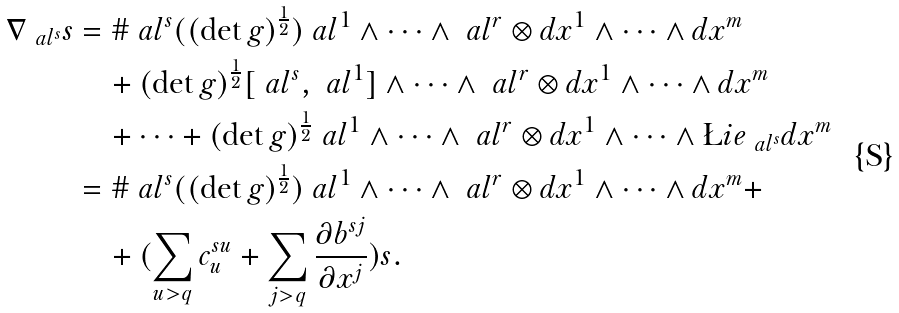<formula> <loc_0><loc_0><loc_500><loc_500>\nabla _ { \ a l ^ { s } } s & = \# \ a l ^ { s } ( ( \det g ) ^ { \frac { 1 } { 2 } } ) \ a l ^ { 1 } \wedge \cdots \wedge \ a l ^ { r } \otimes d x ^ { 1 } \wedge \cdots \wedge d x ^ { m } \\ & \quad + ( \det g ) ^ { \frac { 1 } { 2 } } [ \ a l ^ { s } , \ a l ^ { 1 } ] \wedge \cdots \wedge \ a l ^ { r } \otimes d x ^ { 1 } \wedge \cdots \wedge d x ^ { m } \\ & \quad + \cdots + ( \det g ) ^ { \frac { 1 } { 2 } } \ a l ^ { 1 } \wedge \cdots \wedge \ a l ^ { r } \otimes d x ^ { 1 } \wedge \cdots \wedge \L i e _ { \ a l ^ { s } } d x ^ { m } \\ & = \# \ a l ^ { s } ( ( \det g ) ^ { \frac { 1 } { 2 } } ) \ a l ^ { 1 } \wedge \cdots \wedge \ a l ^ { r } \otimes d x ^ { 1 } \wedge \cdots \wedge d x ^ { m } + \\ & \quad + ( \sum _ { u > q } c ^ { s u } _ { u } + \sum _ { j > q } \frac { \partial b ^ { s j } } { \partial x ^ { j } } ) s .</formula> 